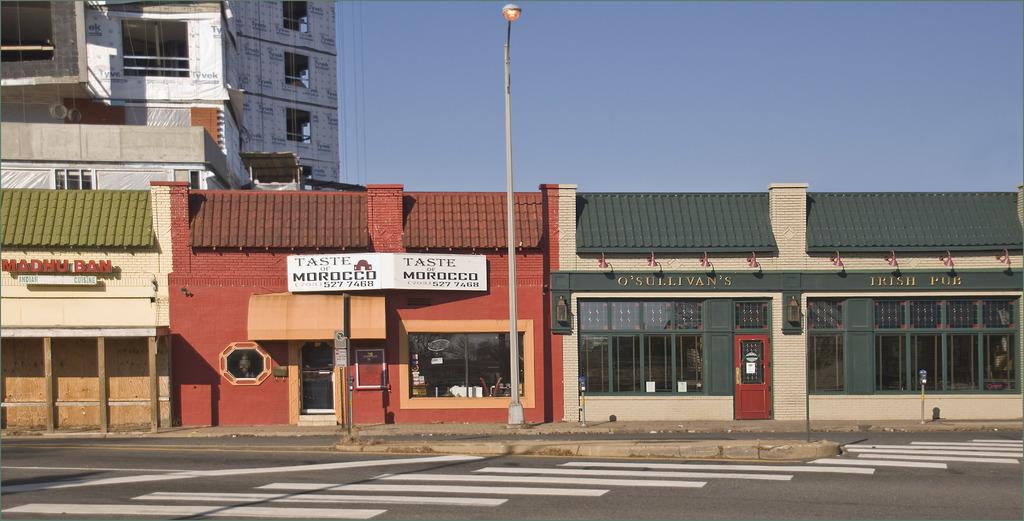What type of structures can be seen in the image? There are buildings in the image. What is the tall, thin object in the image? There is a pole in the image. What type of material is used for the rods in the image? There are metal rods in the image. What is the source of illumination in the image? There is a light in the image. What type of signage is present in the image? There are hoardings in the image. Can you see any mountains in the image? There are no mountains present in the image. What type of rhythm is being played by the buildings in the image? There is no rhythm being played by the buildings in the image; they are stationary structures. 